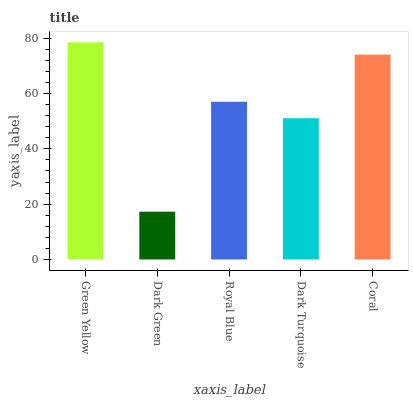Is Dark Green the minimum?
Answer yes or no. Yes. Is Green Yellow the maximum?
Answer yes or no. Yes. Is Royal Blue the minimum?
Answer yes or no. No. Is Royal Blue the maximum?
Answer yes or no. No. Is Royal Blue greater than Dark Green?
Answer yes or no. Yes. Is Dark Green less than Royal Blue?
Answer yes or no. Yes. Is Dark Green greater than Royal Blue?
Answer yes or no. No. Is Royal Blue less than Dark Green?
Answer yes or no. No. Is Royal Blue the high median?
Answer yes or no. Yes. Is Royal Blue the low median?
Answer yes or no. Yes. Is Coral the high median?
Answer yes or no. No. Is Dark Green the low median?
Answer yes or no. No. 